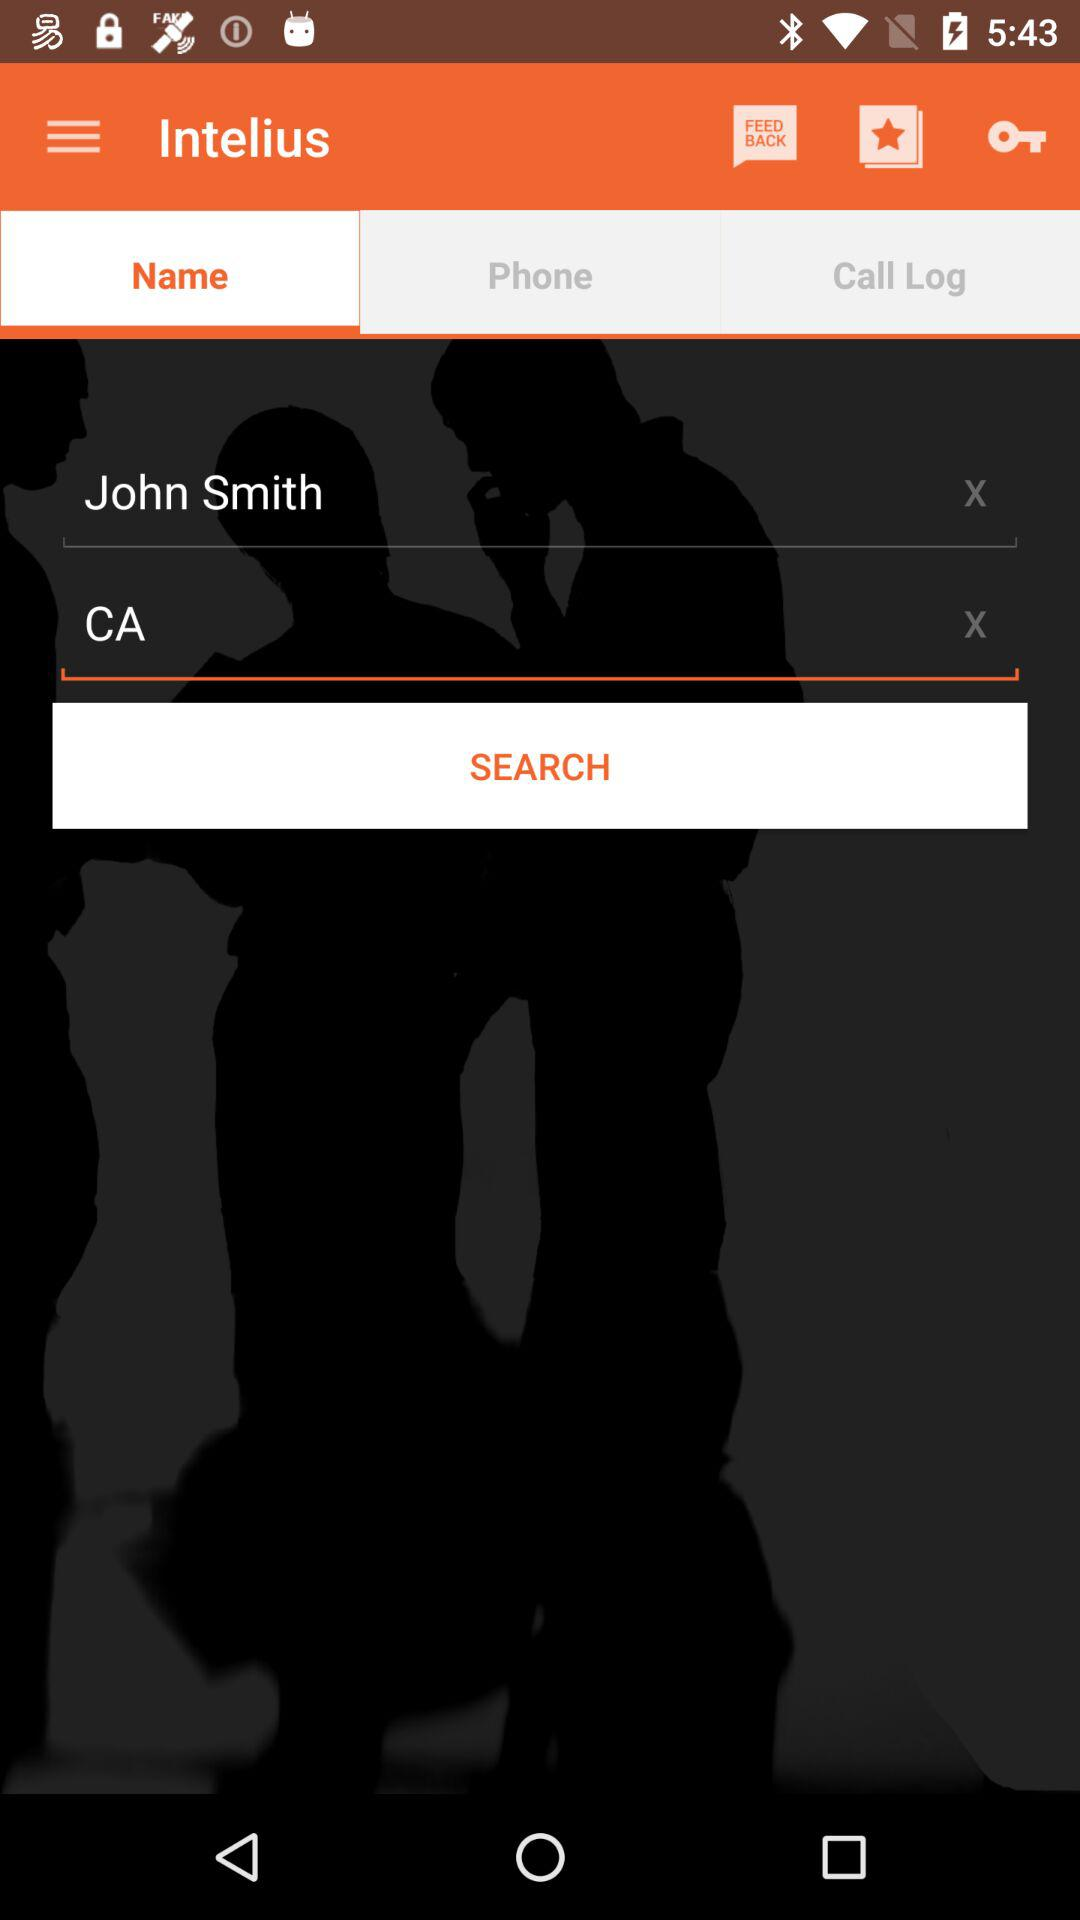What is the person name? The name is John Smith. 